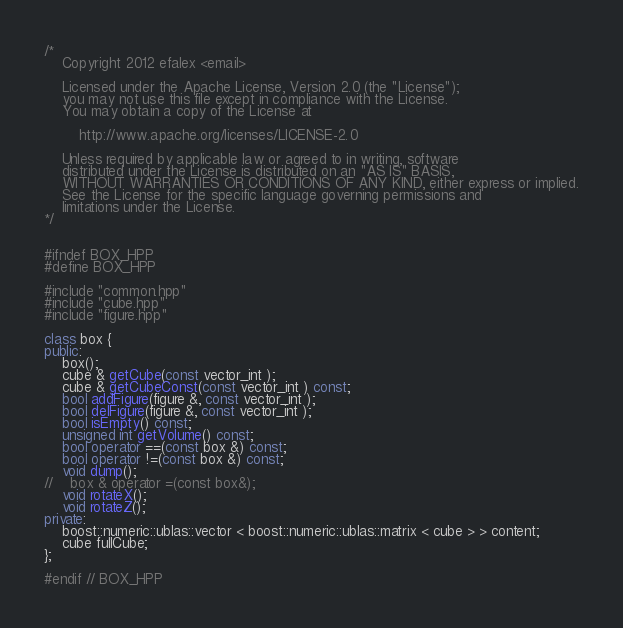<code> <loc_0><loc_0><loc_500><loc_500><_C++_>/*
    Copyright 2012 efalex <email>

    Licensed under the Apache License, Version 2.0 (the "License");
    you may not use this file except in compliance with the License.
    You may obtain a copy of the License at

        http://www.apache.org/licenses/LICENSE-2.0

    Unless required by applicable law or agreed to in writing, software
    distributed under the License is distributed on an "AS IS" BASIS,
    WITHOUT WARRANTIES OR CONDITIONS OF ANY KIND, either express or implied.
    See the License for the specific language governing permissions and
    limitations under the License.
*/


#ifndef BOX_HPP
#define BOX_HPP

#include "common.hpp"
#include "cube.hpp"
#include "figure.hpp"

class box {
public:
    box();
    cube & getCube(const vector_int );
    cube & getCubeConst(const vector_int ) const;
    bool addFigure(figure &, const vector_int );
    bool delFigure(figure &, const vector_int );
    bool isEmpty() const;
    unsigned int getVolume() const;
    bool operator ==(const box &) const;
    bool operator !=(const box &) const;
    void dump();
//    box & operator =(const box&);
    void rotateX();
    void rotateZ();
private:
    boost::numeric::ublas::vector < boost::numeric::ublas::matrix < cube > > content;
    cube fullCube;
};

#endif // BOX_HPP
</code> 